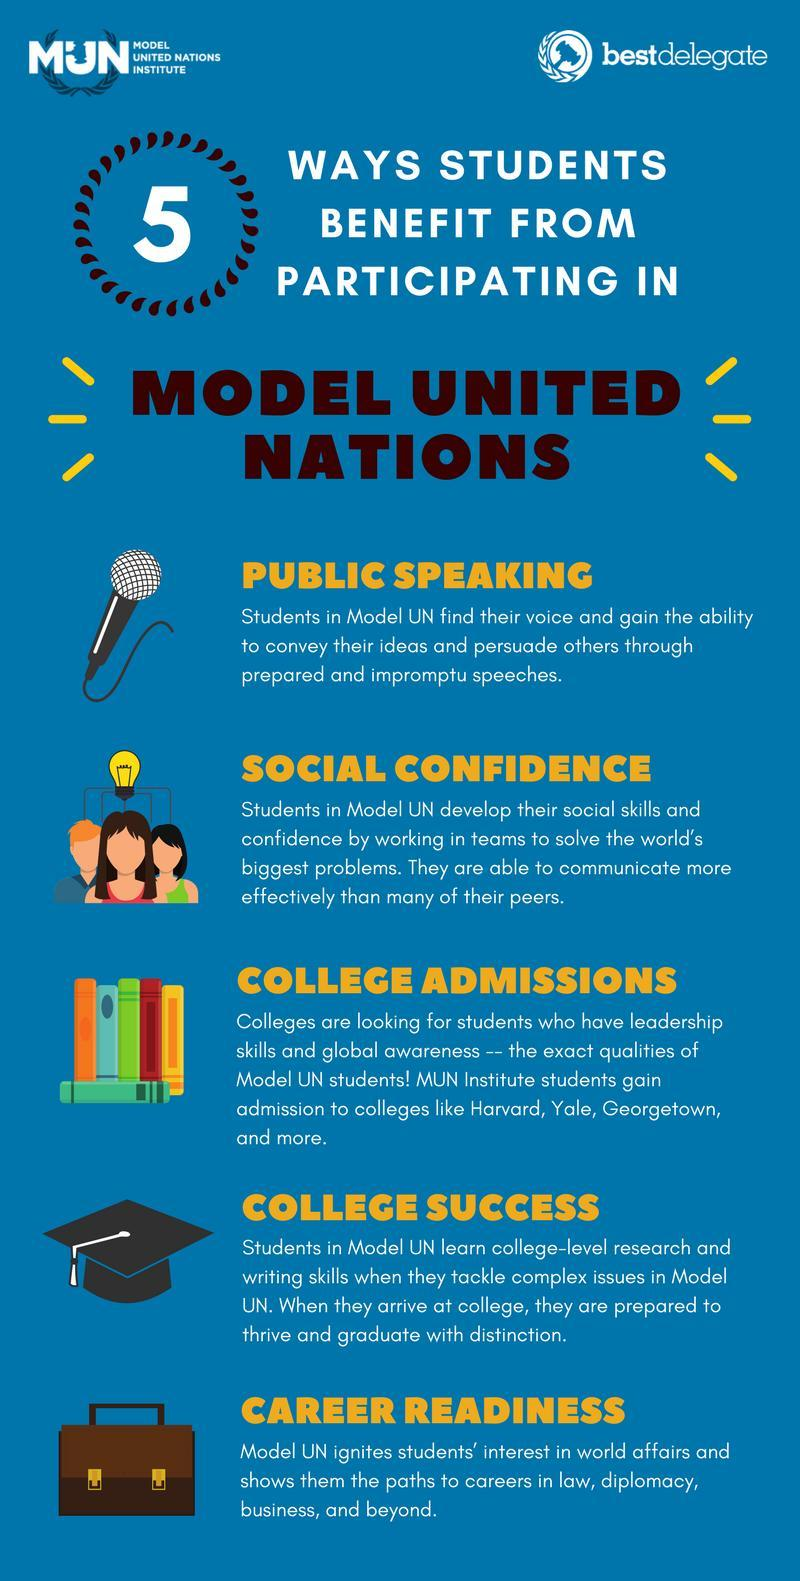what is the colour of the bag, black or brown
Answer the question with a short phrase. brown Other than college admissions and college success, what are the other 3 benefits from paticipating in Model United Nations Public Speaking, Social Confidence, Career Readiness What benefit is highlighted by the microphone image public speaking what benefit does the graduation cap indicate college success 